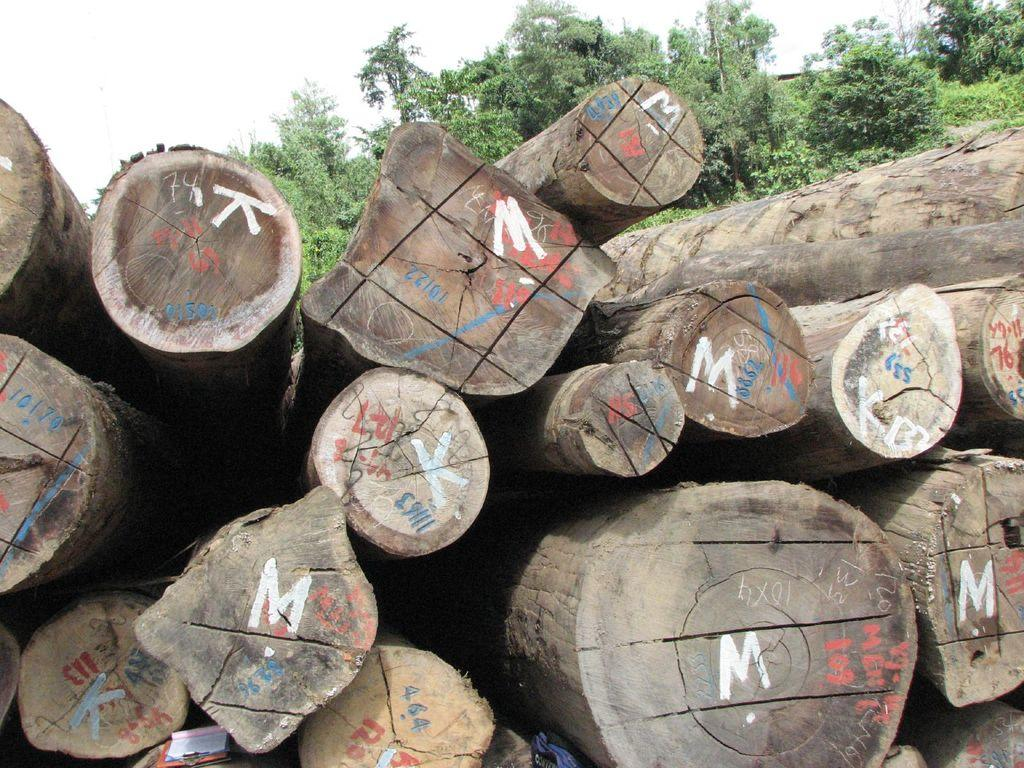What is the main object in the image? There is a log in the image. What can be seen in the background of the image? There are trees in the background of the image. What part of the natural environment is visible in the image? The sky is visible in the image. How many geese are flying over the log in the image? There are no geese present in the image; it only features a log and trees in the background. 